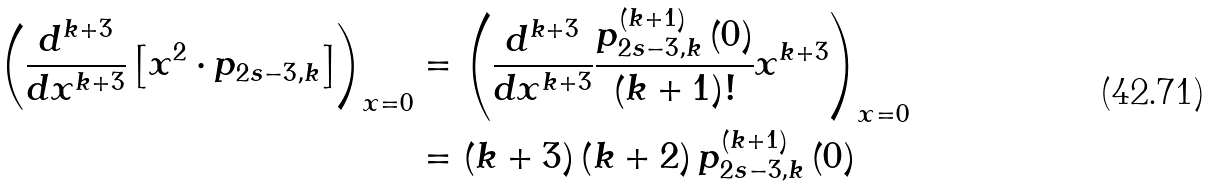<formula> <loc_0><loc_0><loc_500><loc_500>\left ( \frac { d ^ { k + 3 } } { d x ^ { k + 3 } } \left [ x ^ { 2 } \cdot p _ { 2 s - 3 , k } \right ] \right ) _ { x = 0 } & = \left ( \frac { d ^ { k + 3 } } { d x ^ { k + 3 } } \frac { p _ { 2 s - 3 , k } ^ { \left ( k + 1 \right ) } \left ( 0 \right ) } { \left ( k + 1 \right ) ! } x ^ { k + 3 } \right ) _ { x = 0 } \\ & = \left ( k + 3 \right ) \left ( k + 2 \right ) p _ { 2 s - 3 , k } ^ { \left ( k + 1 \right ) } \left ( 0 \right )</formula> 